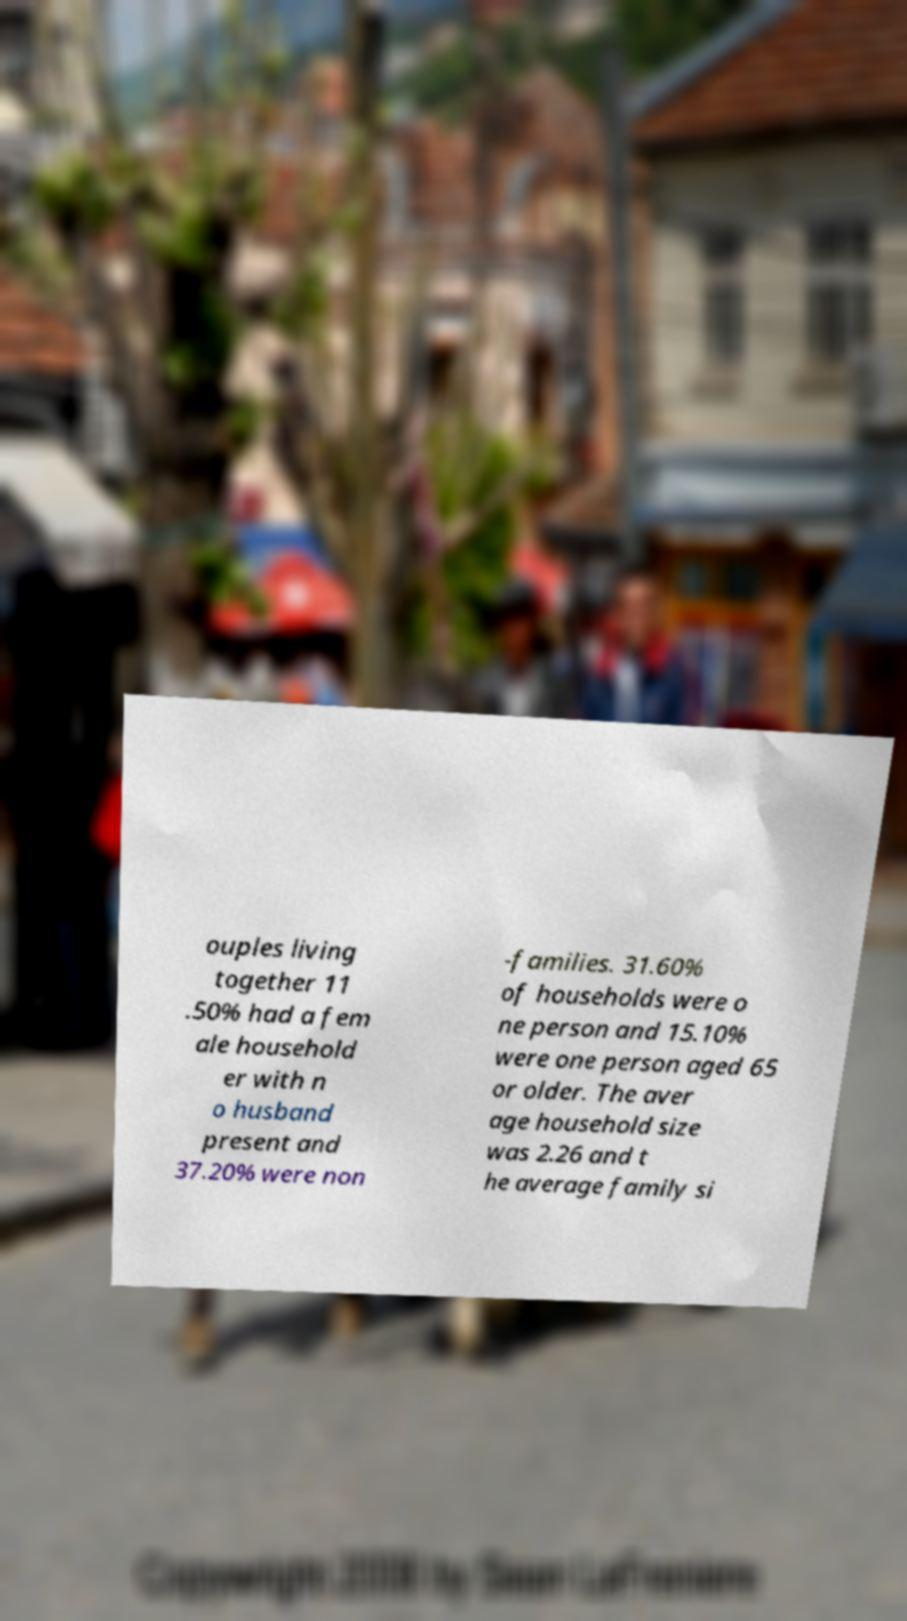Can you read and provide the text displayed in the image?This photo seems to have some interesting text. Can you extract and type it out for me? ouples living together 11 .50% had a fem ale household er with n o husband present and 37.20% were non -families. 31.60% of households were o ne person and 15.10% were one person aged 65 or older. The aver age household size was 2.26 and t he average family si 